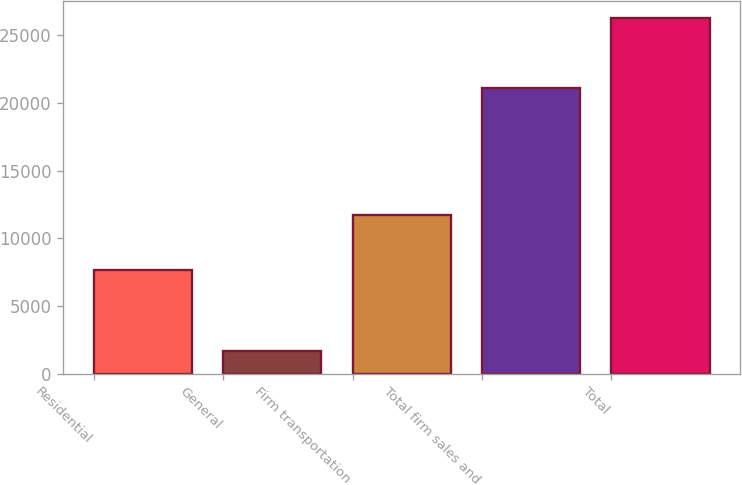<chart> <loc_0><loc_0><loc_500><loc_500><bar_chart><fcel>Residential<fcel>General<fcel>Firm transportation<fcel>Total firm sales and<fcel>Total<nl><fcel>7664<fcel>1684<fcel>11752<fcel>21100<fcel>26236<nl></chart> 